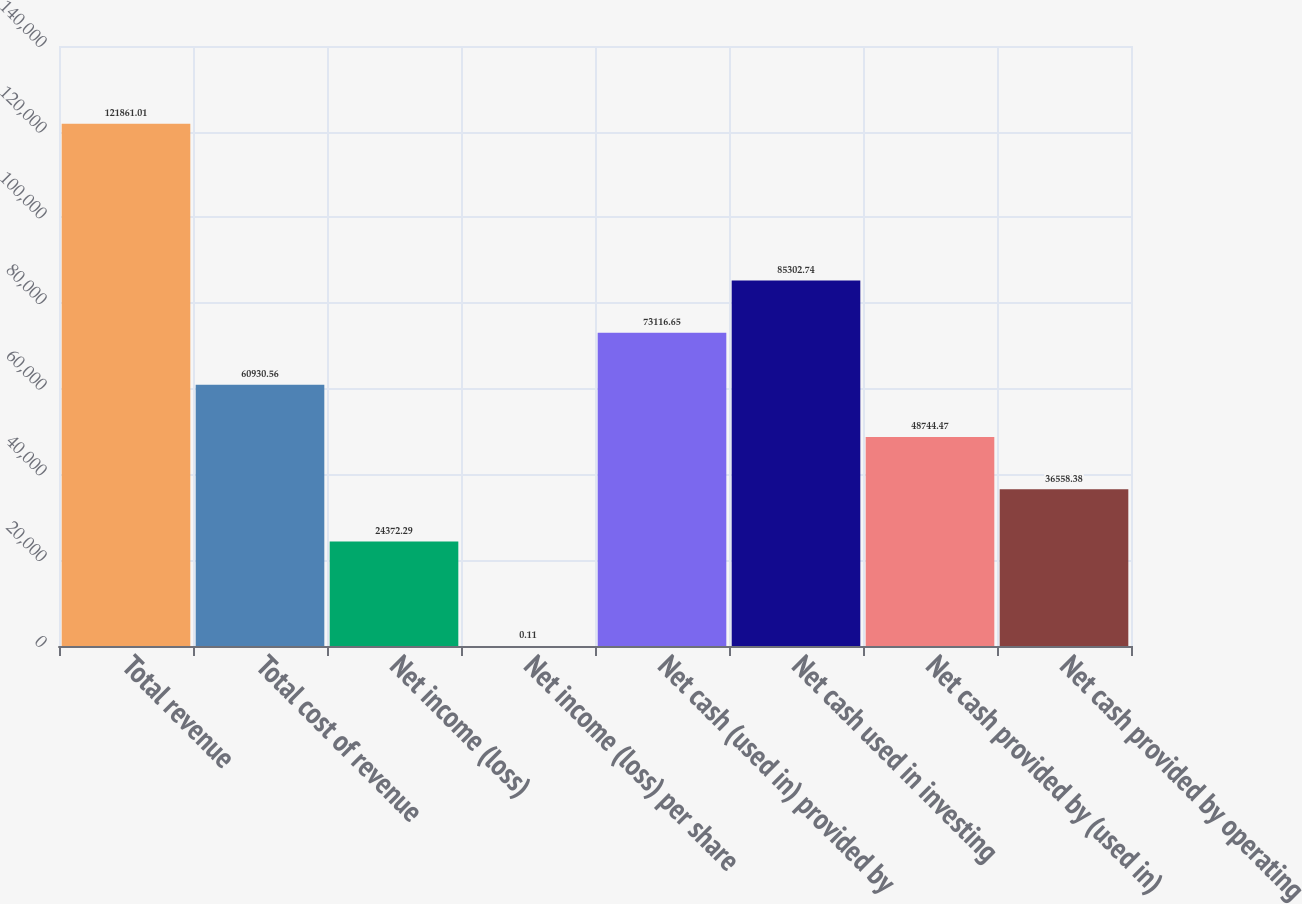Convert chart to OTSL. <chart><loc_0><loc_0><loc_500><loc_500><bar_chart><fcel>Total revenue<fcel>Total cost of revenue<fcel>Net income (loss)<fcel>Net income (loss) per share<fcel>Net cash (used in) provided by<fcel>Net cash used in investing<fcel>Net cash provided by (used in)<fcel>Net cash provided by operating<nl><fcel>121861<fcel>60930.6<fcel>24372.3<fcel>0.11<fcel>73116.6<fcel>85302.7<fcel>48744.5<fcel>36558.4<nl></chart> 